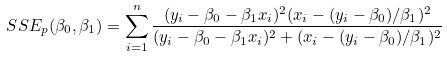Convert formula to latex. <formula><loc_0><loc_0><loc_500><loc_500>S S E _ { p } ( \beta _ { 0 } , \beta _ { 1 } ) = \sum _ { i = 1 } ^ { n } \frac { ( y _ { i } - \beta _ { 0 } - \beta _ { 1 } x _ { i } ) ^ { 2 } ( x _ { i } - ( y _ { i } - \beta _ { 0 } ) / \beta _ { 1 } ) ^ { 2 } } { ( y _ { i } - \beta _ { 0 } - \beta _ { 1 } x _ { i } ) ^ { 2 } + ( x _ { i } - ( y _ { i } - \beta _ { 0 } ) / \beta _ { 1 } ) ^ { 2 } }</formula> 